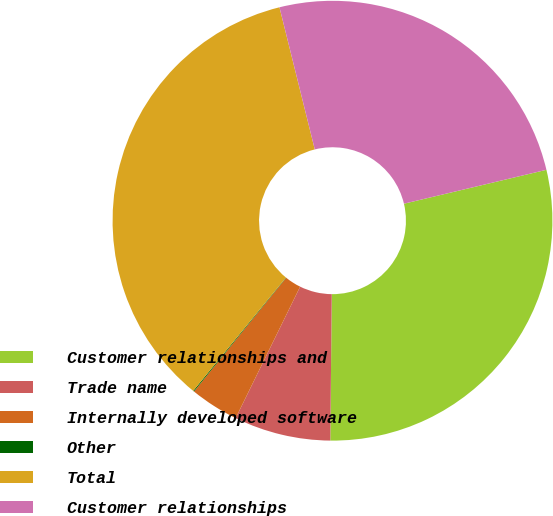Convert chart to OTSL. <chart><loc_0><loc_0><loc_500><loc_500><pie_chart><fcel>Customer relationships and<fcel>Trade name<fcel>Internally developed software<fcel>Other<fcel>Total<fcel>Customer relationships<nl><fcel>28.88%<fcel>7.1%<fcel>3.59%<fcel>0.07%<fcel>35.21%<fcel>25.16%<nl></chart> 